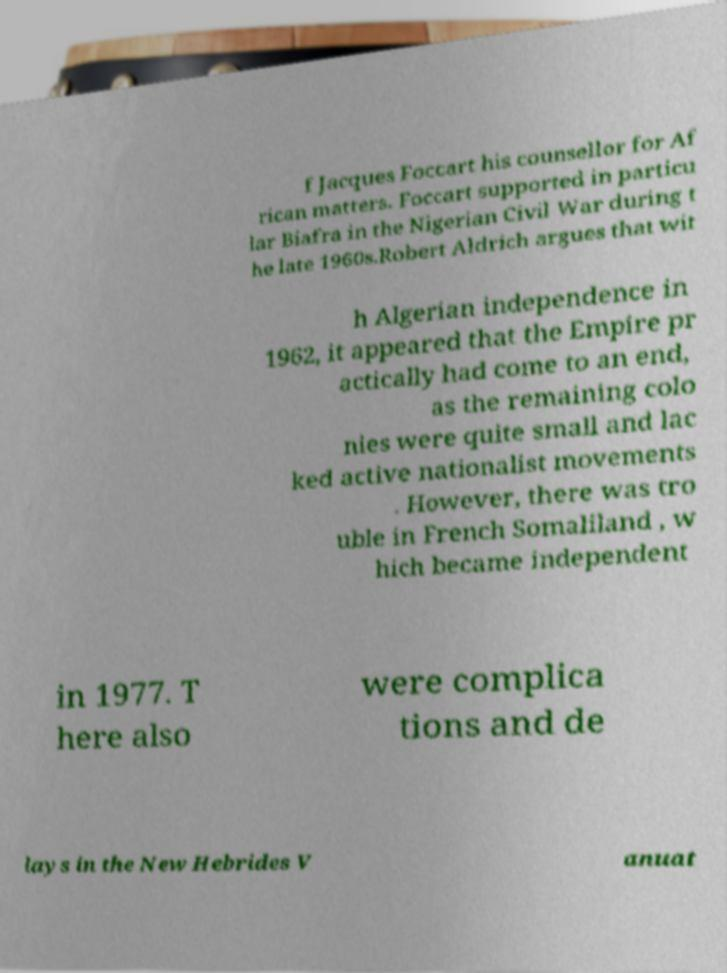Can you accurately transcribe the text from the provided image for me? f Jacques Foccart his counsellor for Af rican matters. Foccart supported in particu lar Biafra in the Nigerian Civil War during t he late 1960s.Robert Aldrich argues that wit h Algerian independence in 1962, it appeared that the Empire pr actically had come to an end, as the remaining colo nies were quite small and lac ked active nationalist movements . However, there was tro uble in French Somaliland , w hich became independent in 1977. T here also were complica tions and de lays in the New Hebrides V anuat 